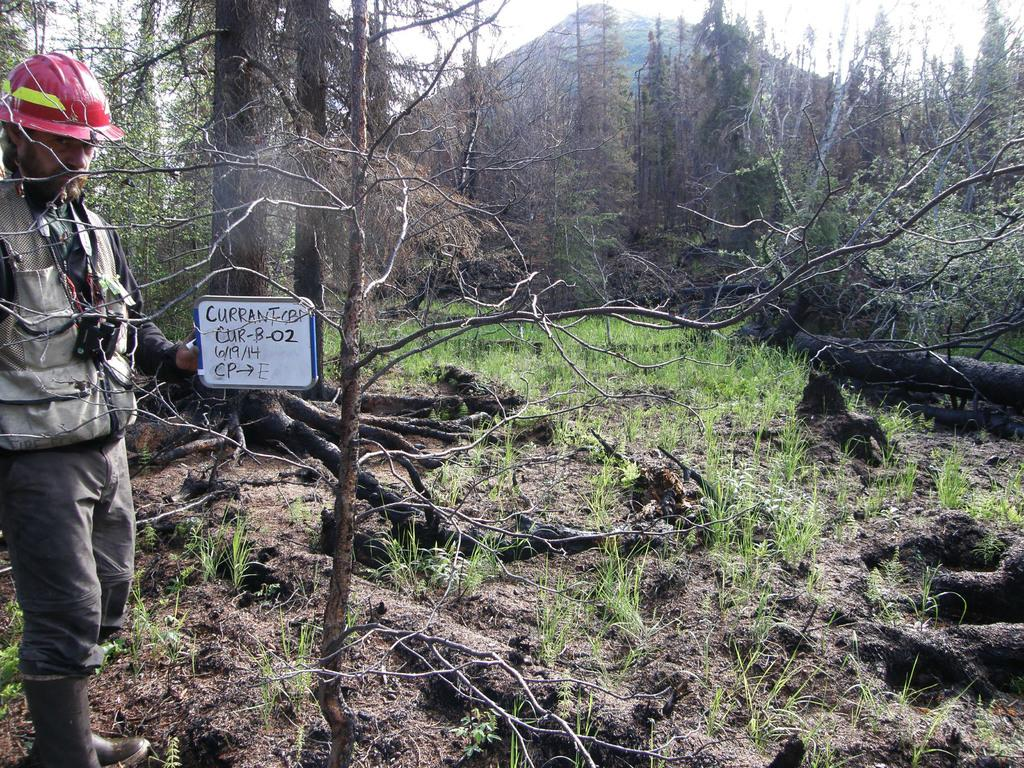What is the person on the left side of the image holding? The person is holding a board in the image. What type of natural landscape can be seen in the image? There is a mountain visible in the image, along with trees and grass. What type of lace can be seen on the person's clothing in the image? There is no lace visible on the person's clothing in the image. Is there a tiger present in the image? No, there is no tiger present in the image. 